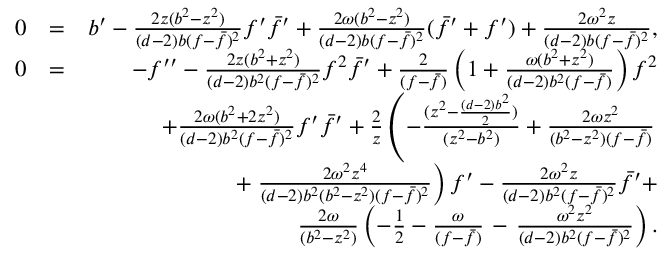Convert formula to latex. <formula><loc_0><loc_0><loc_500><loc_500>\begin{array} { r l r } { 0 } & { = } & { b ^ { \prime } - { \frac { 2 z ( b ^ { 2 } - z ^ { 2 } ) } { ( d - 2 ) b ( f - \bar { f } ) ^ { 2 } } } f ^ { \prime } \bar { f } ^ { \prime } + { \frac { 2 \omega ( b ^ { 2 } - z ^ { 2 } ) } { ( d - 2 ) b ( f - \bar { f } ) ^ { 2 } } } ( \bar { f } ^ { \prime } + f ^ { \prime } ) + { \frac { 2 \omega ^ { 2 } z } { ( d - 2 ) b ( f - \bar { f } ) ^ { 2 } } } , } \\ { 0 } & { = } & { - f ^ { \prime \prime } - { \frac { 2 z ( b ^ { 2 } + z ^ { 2 } ) } { ( d - 2 ) b ^ { 2 } ( f - \bar { f } ) ^ { 2 } } } f ^ { 2 } \bar { f } ^ { \prime } + { \frac { 2 } { ( f - \bar { f } ) } } \left ( 1 + { \frac { \omega ( b ^ { 2 } + z ^ { 2 } ) } { ( d - 2 ) b ^ { 2 } ( f - \bar { f } ) } } \right ) f ^ { 2 } } \\ & { + { \frac { 2 \omega ( b ^ { 2 } + 2 z ^ { 2 } ) } { ( d - 2 ) b ^ { 2 } ( f - \bar { f } ) ^ { 2 } } } f ^ { \prime } \bar { f } ^ { \prime } + { \frac { 2 } { z } } \left ( - \frac { ( z ^ { 2 } - \frac { ( d - 2 ) b ^ { 2 } } { 2 } ) } { ( z ^ { 2 } - b ^ { 2 } ) } + { \frac { 2 \omega z ^ { 2 } } { ( b ^ { 2 } - z ^ { 2 } ) ( f - \bar { f } ) } } } \\ & { + { \frac { 2 \omega ^ { 2 } z ^ { 4 } } { ( d - 2 ) b ^ { 2 } ( b ^ { 2 } - z ^ { 2 } ) ( f - \bar { f } ) ^ { 2 } } } \right ) f ^ { \prime } - { \frac { 2 \omega ^ { 2 } z } { ( d - 2 ) b ^ { 2 } ( f - \bar { f } ) ^ { 2 } } } \bar { f } ^ { \prime } + } \\ & { { \frac { 2 \omega } { ( b ^ { 2 } - z ^ { 2 } ) } } \left ( - \frac { 1 } { 2 } - { \frac { \omega } { ( f - \bar { f } ) } } - { \frac { \omega ^ { 2 } z ^ { 2 } } { ( d - 2 ) b ^ { 2 } ( f - \bar { f } ) ^ { 2 } } } \right ) . } \end{array}</formula> 